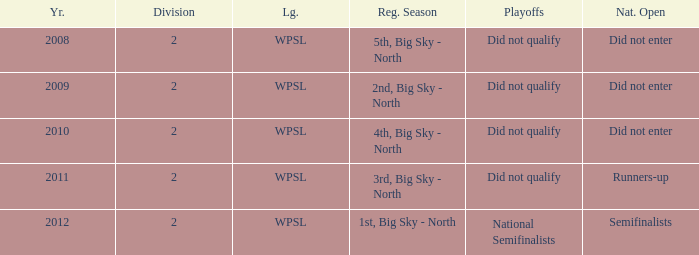What is the lowest division number? 2.0. 